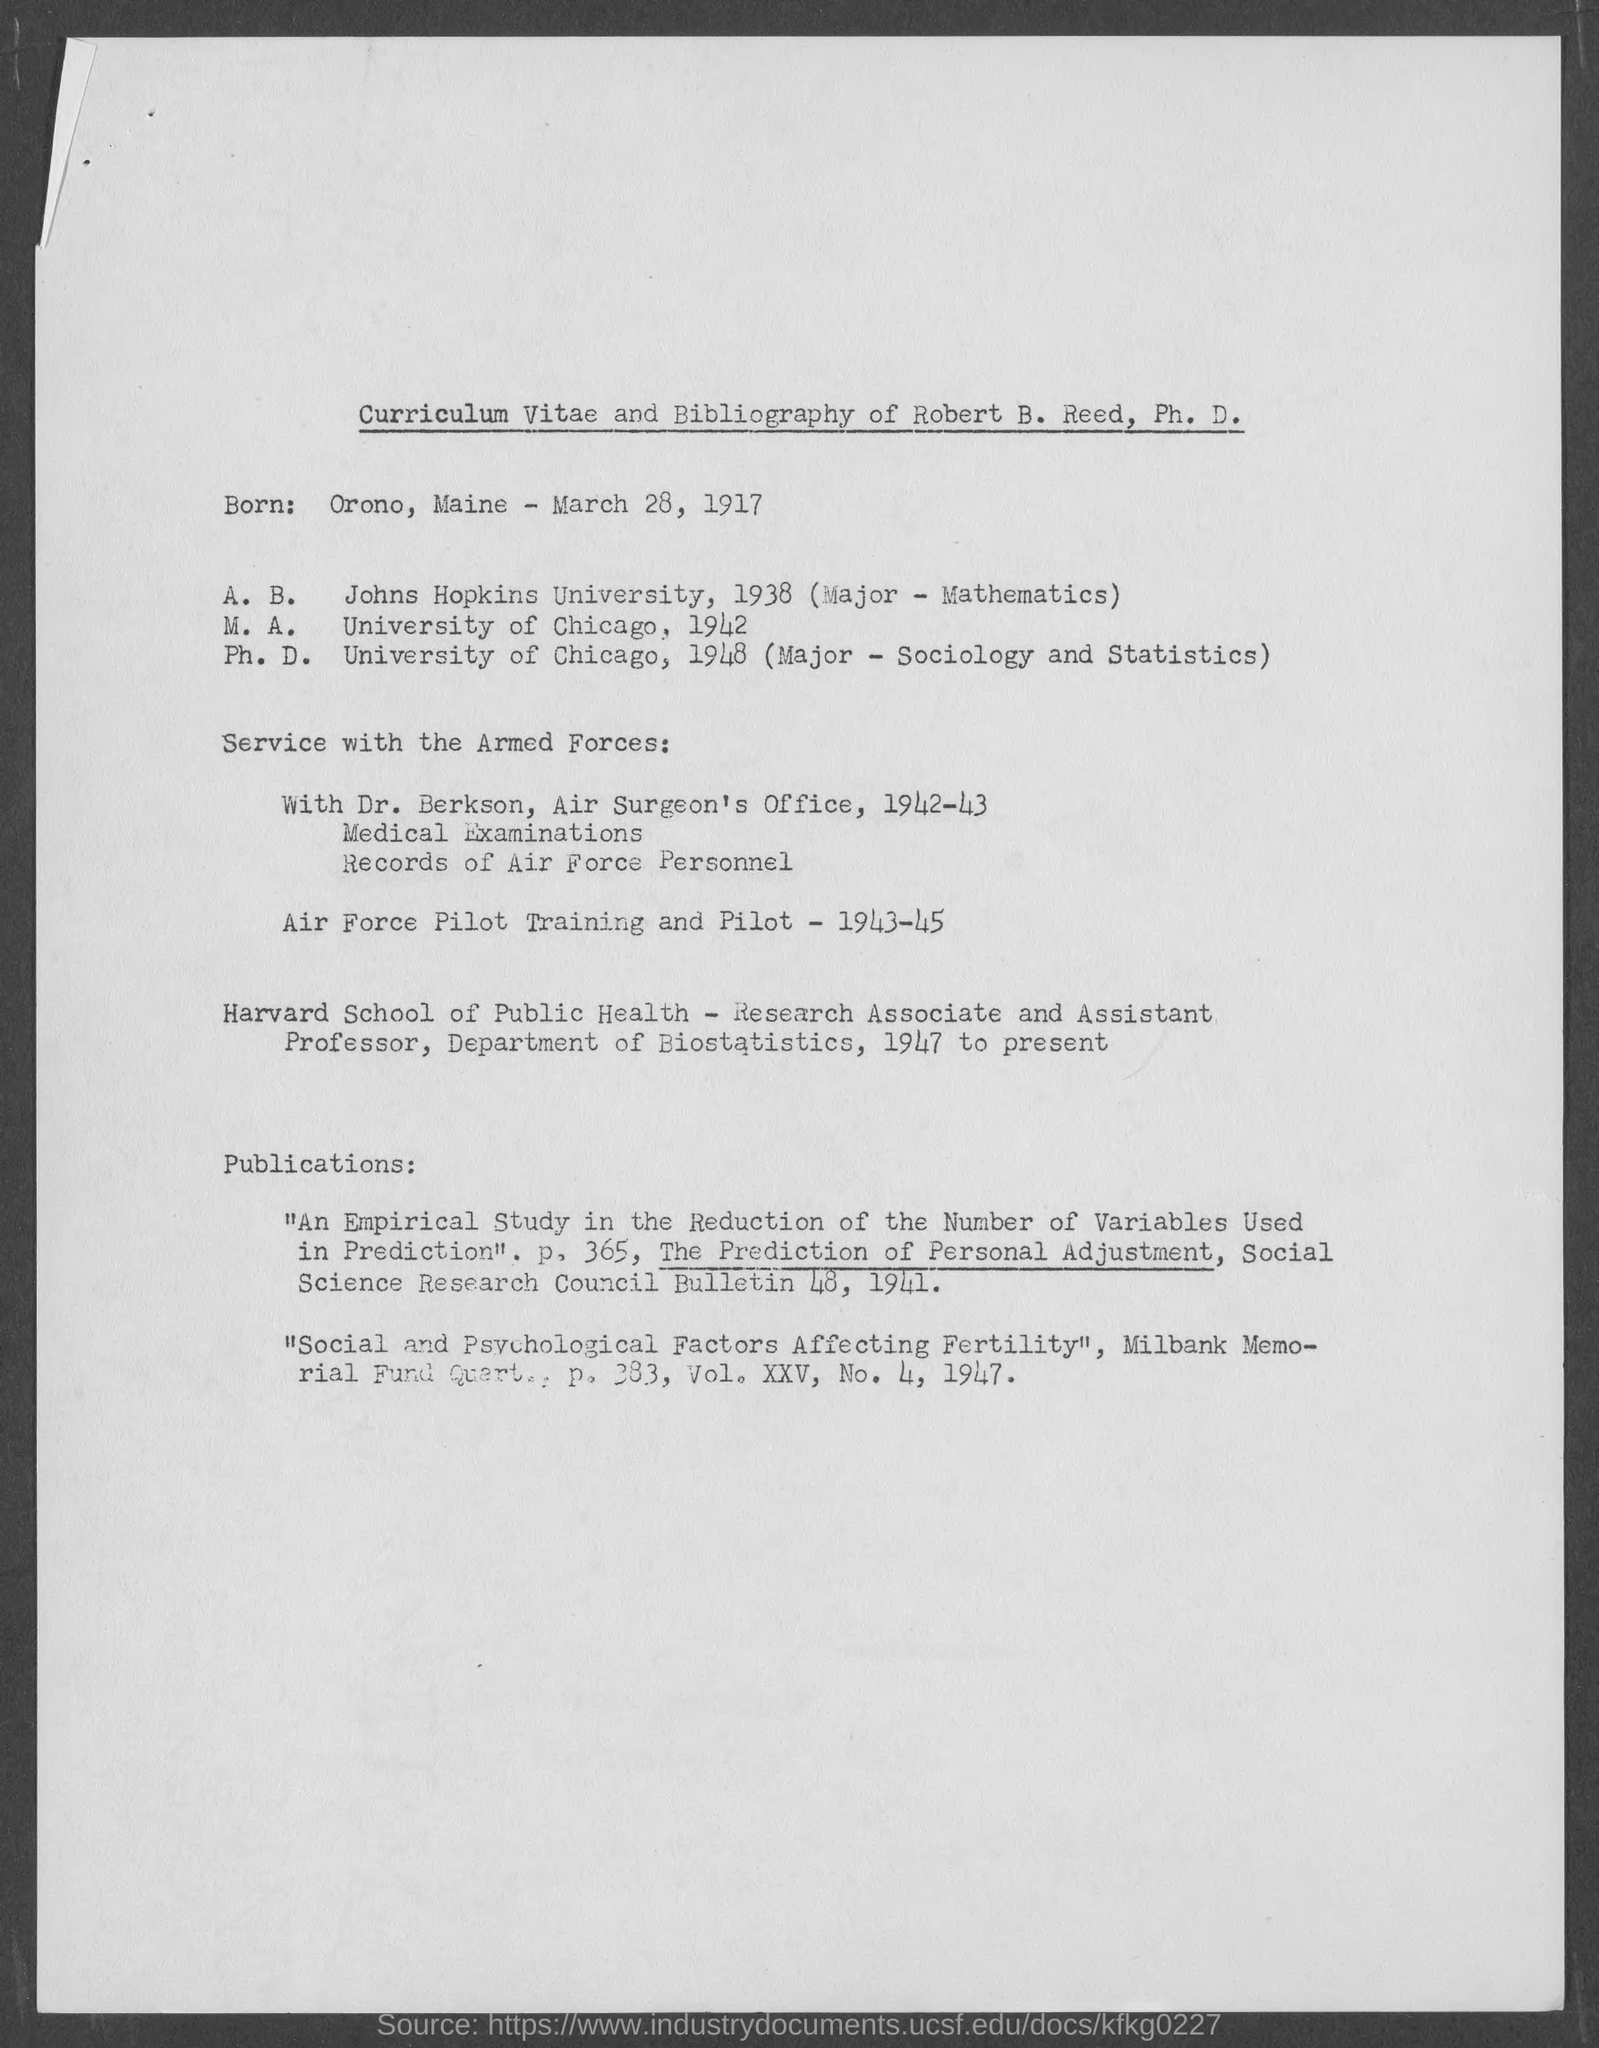Indicate a few pertinent items in this graphic. Robert B. Reed, Ph.D., was born in Orono, Maine. Robert B. Reed completed his Master of Arts degree from the University of Chicago. Robert B. Reed completed his Ph.D. in 1948. Robert B. Reed earned a Ph.D. in Sociology and Statistics. Robert B. Reed, Ph.D. was born on March 28, 1917. 